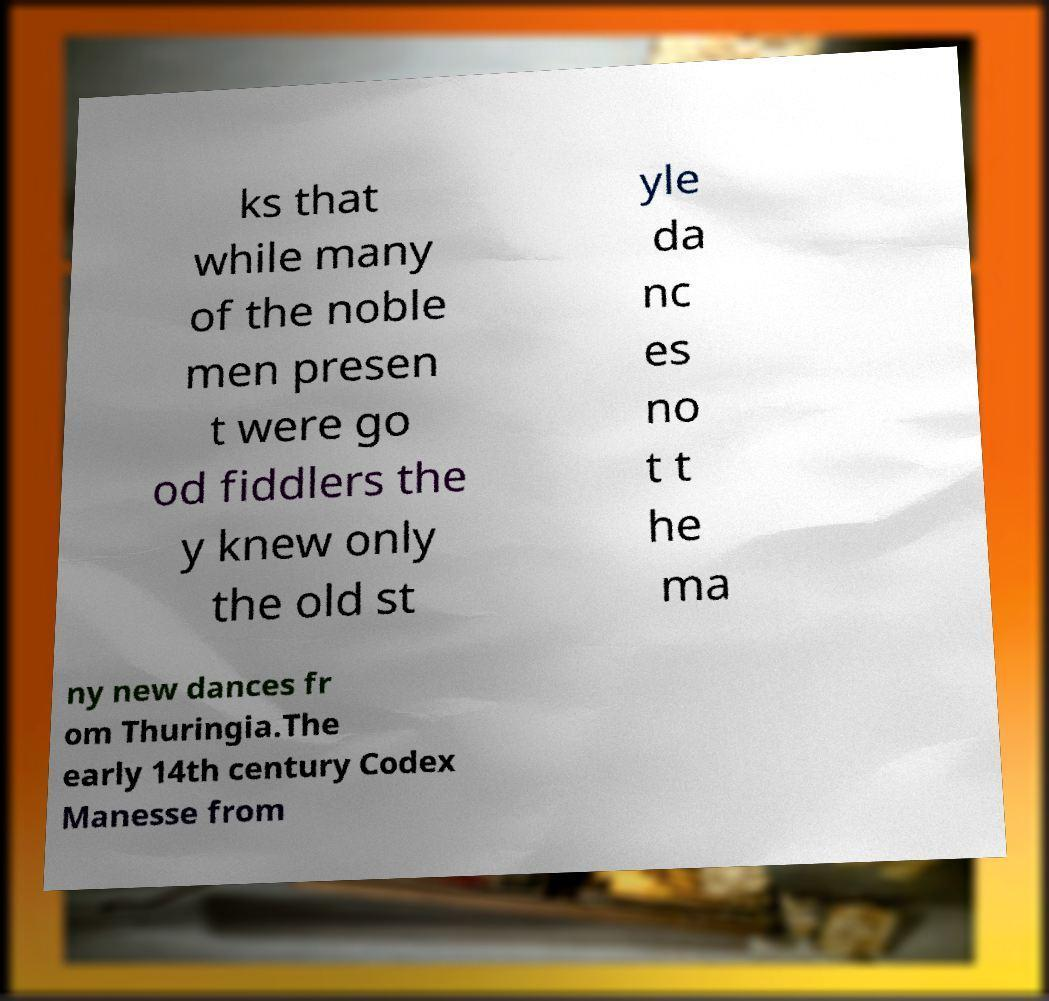Could you extract and type out the text from this image? ks that while many of the noble men presen t were go od fiddlers the y knew only the old st yle da nc es no t t he ma ny new dances fr om Thuringia.The early 14th century Codex Manesse from 